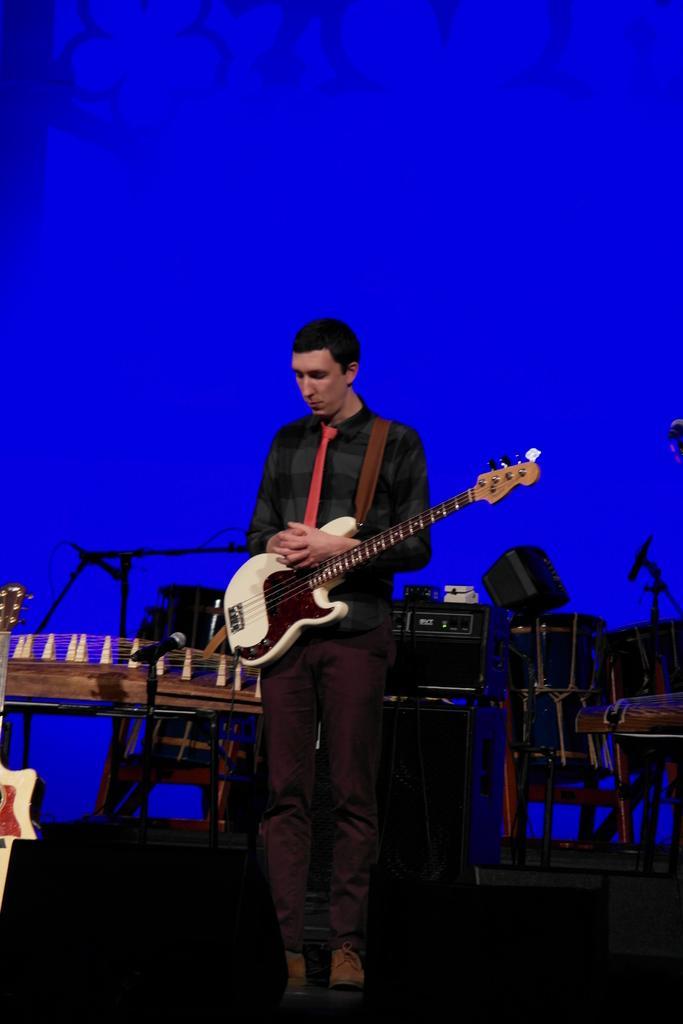In one or two sentences, can you explain what this image depicts? In the center of the image there is a man standing and holding a guitar in his hand. In the background there are drums, speaker and a mic 